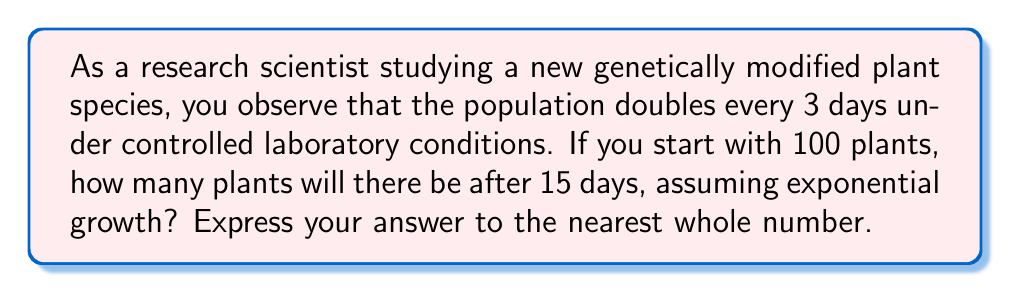Can you answer this question? Let's approach this step-by-step:

1) The exponential growth function is given by:
   $$N(t) = N_0 \cdot e^{rt}$$
   where $N(t)$ is the population at time $t$, $N_0$ is the initial population, $r$ is the growth rate, and $t$ is time.

2) We know that the population doubles every 3 days. We can use this to find $r$:
   $$2 = e^{3r}$$
   $$\ln(2) = 3r$$
   $$r = \frac{\ln(2)}{3}$$

3) Now we have:
   $$N(t) = 100 \cdot e^{\frac{\ln(2)}{3}t}$$

4) We want to know $N(15)$:
   $$N(15) = 100 \cdot e^{\frac{\ln(2)}{3} \cdot 15}$$

5) Simplify:
   $$N(15) = 100 \cdot e^{5\ln(2)}$$
   $$N(15) = 100 \cdot (e^{\ln(2)})^5$$
   $$N(15) = 100 \cdot 2^5$$
   $$N(15) = 100 \cdot 32 = 3200$$

Therefore, after 15 days, there will be 3200 plants.
Answer: 3200 plants 